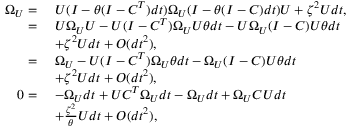<formula> <loc_0><loc_0><loc_500><loc_500>\begin{array} { r l } { \Omega _ { U } = } & { \ U ( I - \theta ( I - C ^ { T } ) d t ) \Omega _ { U } ( I - \theta ( I - C ) d t ) U + \zeta ^ { 2 } U d t , } \\ { = } & { \ U \Omega _ { U } U - U ( I - C ^ { T } ) \Omega _ { U } U \theta d t - U \Omega _ { U } ( I - C ) U \theta d t } \\ & { \ + \zeta ^ { 2 } U d t + O ( d t ^ { 2 } ) , } \\ { = } & { \ \Omega _ { U } - U ( I - C ^ { T } ) \Omega _ { U } \theta d t - \Omega _ { U } ( I - C ) U \theta d t } \\ & { \ + \zeta ^ { 2 } U d t + O ( d t ^ { 2 } ) , } \\ { 0 = } & { \ - \Omega _ { U } d t + U C ^ { T } \Omega _ { U } d t - \Omega _ { U } d t + \Omega _ { U } C U d t } \\ & { \ + \frac { \zeta ^ { 2 } } { \theta } U d t + O ( d t ^ { 2 } ) , } \end{array}</formula> 